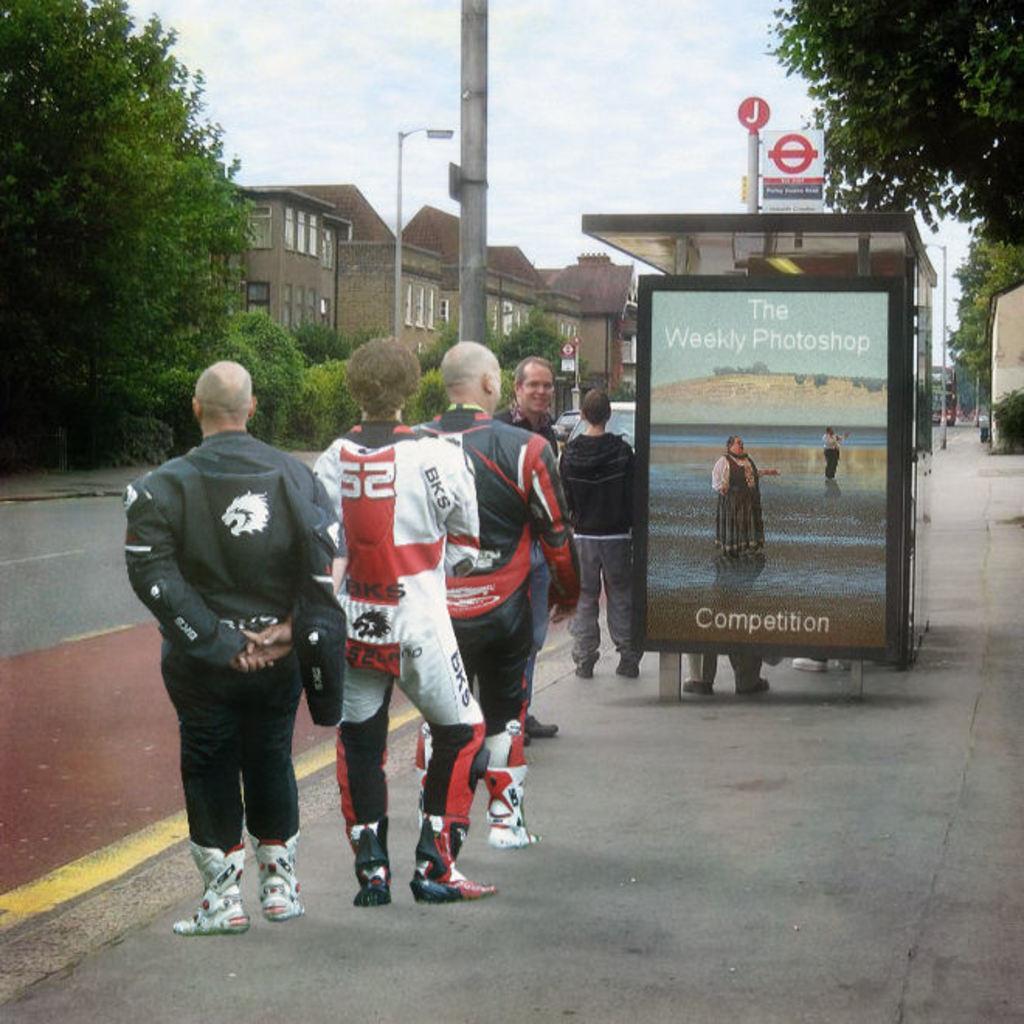How would you summarize this image in a sentence or two? In this picture, there are group of people standing in a line on a footpath. Among them, four are facing backwards and one of them facing forward. Beside them, there is a board with some picture. Towards the top left, there are trees, buildings and poles. Towards the top right, there is a tree and a vehicle. 